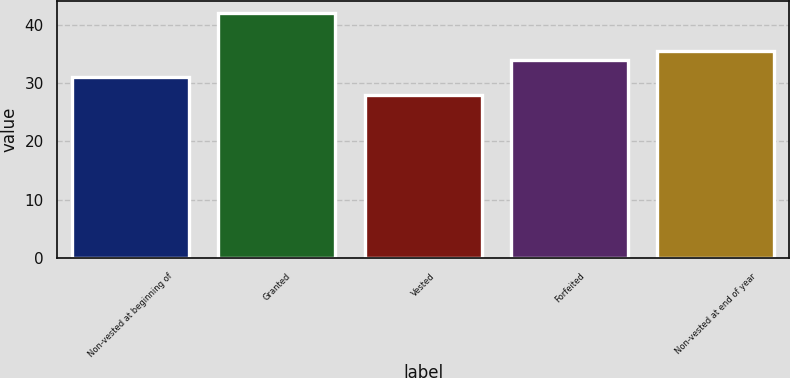Convert chart. <chart><loc_0><loc_0><loc_500><loc_500><bar_chart><fcel>Non-vested at beginning of<fcel>Granted<fcel>Vested<fcel>Forfeited<fcel>Non-vested at end of year<nl><fcel>31<fcel>42<fcel>28<fcel>34<fcel>35.4<nl></chart> 